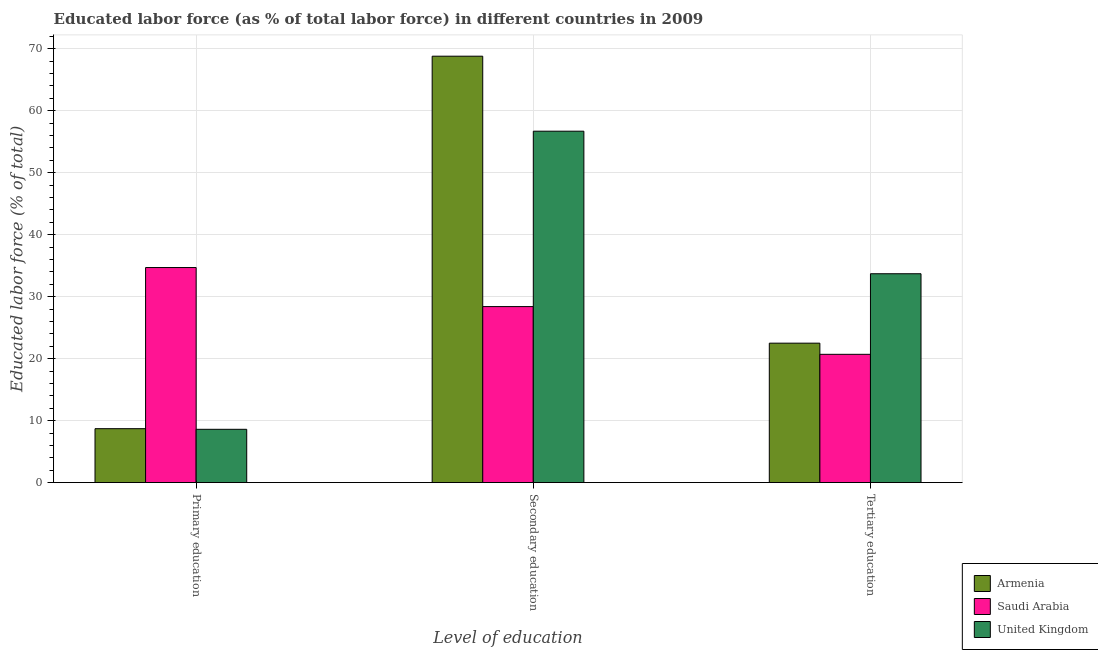Are the number of bars on each tick of the X-axis equal?
Give a very brief answer. Yes. How many bars are there on the 1st tick from the left?
Provide a short and direct response. 3. What is the percentage of labor force who received tertiary education in Saudi Arabia?
Your answer should be compact. 20.7. Across all countries, what is the maximum percentage of labor force who received tertiary education?
Provide a succinct answer. 33.7. Across all countries, what is the minimum percentage of labor force who received primary education?
Your answer should be compact. 8.6. In which country was the percentage of labor force who received primary education maximum?
Provide a succinct answer. Saudi Arabia. In which country was the percentage of labor force who received tertiary education minimum?
Provide a succinct answer. Saudi Arabia. What is the total percentage of labor force who received secondary education in the graph?
Offer a very short reply. 153.9. What is the difference between the percentage of labor force who received tertiary education in United Kingdom and that in Armenia?
Provide a short and direct response. 11.2. What is the difference between the percentage of labor force who received secondary education in United Kingdom and the percentage of labor force who received primary education in Armenia?
Your response must be concise. 48. What is the average percentage of labor force who received primary education per country?
Your response must be concise. 17.33. What is the difference between the percentage of labor force who received tertiary education and percentage of labor force who received primary education in Saudi Arabia?
Ensure brevity in your answer.  -14. What is the ratio of the percentage of labor force who received secondary education in Armenia to that in Saudi Arabia?
Ensure brevity in your answer.  2.42. Is the percentage of labor force who received secondary education in United Kingdom less than that in Armenia?
Give a very brief answer. Yes. Is the difference between the percentage of labor force who received tertiary education in Saudi Arabia and United Kingdom greater than the difference between the percentage of labor force who received secondary education in Saudi Arabia and United Kingdom?
Ensure brevity in your answer.  Yes. What is the difference between the highest and the second highest percentage of labor force who received tertiary education?
Give a very brief answer. 11.2. What is the difference between the highest and the lowest percentage of labor force who received tertiary education?
Offer a very short reply. 13. In how many countries, is the percentage of labor force who received secondary education greater than the average percentage of labor force who received secondary education taken over all countries?
Your answer should be compact. 2. What does the 3rd bar from the right in Tertiary education represents?
Offer a very short reply. Armenia. Is it the case that in every country, the sum of the percentage of labor force who received primary education and percentage of labor force who received secondary education is greater than the percentage of labor force who received tertiary education?
Make the answer very short. Yes. How many countries are there in the graph?
Provide a short and direct response. 3. Where does the legend appear in the graph?
Your answer should be compact. Bottom right. How are the legend labels stacked?
Provide a succinct answer. Vertical. What is the title of the graph?
Provide a short and direct response. Educated labor force (as % of total labor force) in different countries in 2009. Does "Middle East & North Africa (all income levels)" appear as one of the legend labels in the graph?
Your answer should be compact. No. What is the label or title of the X-axis?
Give a very brief answer. Level of education. What is the label or title of the Y-axis?
Your response must be concise. Educated labor force (% of total). What is the Educated labor force (% of total) in Armenia in Primary education?
Offer a very short reply. 8.7. What is the Educated labor force (% of total) in Saudi Arabia in Primary education?
Provide a succinct answer. 34.7. What is the Educated labor force (% of total) in United Kingdom in Primary education?
Offer a terse response. 8.6. What is the Educated labor force (% of total) in Armenia in Secondary education?
Your answer should be compact. 68.8. What is the Educated labor force (% of total) in Saudi Arabia in Secondary education?
Make the answer very short. 28.4. What is the Educated labor force (% of total) in United Kingdom in Secondary education?
Your answer should be compact. 56.7. What is the Educated labor force (% of total) in Saudi Arabia in Tertiary education?
Make the answer very short. 20.7. What is the Educated labor force (% of total) of United Kingdom in Tertiary education?
Offer a terse response. 33.7. Across all Level of education, what is the maximum Educated labor force (% of total) in Armenia?
Ensure brevity in your answer.  68.8. Across all Level of education, what is the maximum Educated labor force (% of total) in Saudi Arabia?
Keep it short and to the point. 34.7. Across all Level of education, what is the maximum Educated labor force (% of total) in United Kingdom?
Provide a succinct answer. 56.7. Across all Level of education, what is the minimum Educated labor force (% of total) of Armenia?
Provide a succinct answer. 8.7. Across all Level of education, what is the minimum Educated labor force (% of total) of Saudi Arabia?
Make the answer very short. 20.7. Across all Level of education, what is the minimum Educated labor force (% of total) of United Kingdom?
Your answer should be very brief. 8.6. What is the total Educated labor force (% of total) in Saudi Arabia in the graph?
Your answer should be very brief. 83.8. What is the total Educated labor force (% of total) in United Kingdom in the graph?
Provide a succinct answer. 99. What is the difference between the Educated labor force (% of total) in Armenia in Primary education and that in Secondary education?
Give a very brief answer. -60.1. What is the difference between the Educated labor force (% of total) of Saudi Arabia in Primary education and that in Secondary education?
Your response must be concise. 6.3. What is the difference between the Educated labor force (% of total) of United Kingdom in Primary education and that in Secondary education?
Offer a very short reply. -48.1. What is the difference between the Educated labor force (% of total) in Saudi Arabia in Primary education and that in Tertiary education?
Provide a succinct answer. 14. What is the difference between the Educated labor force (% of total) in United Kingdom in Primary education and that in Tertiary education?
Provide a succinct answer. -25.1. What is the difference between the Educated labor force (% of total) in Armenia in Secondary education and that in Tertiary education?
Offer a terse response. 46.3. What is the difference between the Educated labor force (% of total) in Saudi Arabia in Secondary education and that in Tertiary education?
Make the answer very short. 7.7. What is the difference between the Educated labor force (% of total) in Armenia in Primary education and the Educated labor force (% of total) in Saudi Arabia in Secondary education?
Provide a succinct answer. -19.7. What is the difference between the Educated labor force (% of total) of Armenia in Primary education and the Educated labor force (% of total) of United Kingdom in Secondary education?
Ensure brevity in your answer.  -48. What is the difference between the Educated labor force (% of total) of Saudi Arabia in Primary education and the Educated labor force (% of total) of United Kingdom in Secondary education?
Offer a terse response. -22. What is the difference between the Educated labor force (% of total) in Armenia in Primary education and the Educated labor force (% of total) in Saudi Arabia in Tertiary education?
Provide a succinct answer. -12. What is the difference between the Educated labor force (% of total) in Armenia in Primary education and the Educated labor force (% of total) in United Kingdom in Tertiary education?
Your answer should be compact. -25. What is the difference between the Educated labor force (% of total) in Saudi Arabia in Primary education and the Educated labor force (% of total) in United Kingdom in Tertiary education?
Offer a very short reply. 1. What is the difference between the Educated labor force (% of total) in Armenia in Secondary education and the Educated labor force (% of total) in Saudi Arabia in Tertiary education?
Provide a short and direct response. 48.1. What is the difference between the Educated labor force (% of total) in Armenia in Secondary education and the Educated labor force (% of total) in United Kingdom in Tertiary education?
Your response must be concise. 35.1. What is the difference between the Educated labor force (% of total) in Saudi Arabia in Secondary education and the Educated labor force (% of total) in United Kingdom in Tertiary education?
Provide a succinct answer. -5.3. What is the average Educated labor force (% of total) of Armenia per Level of education?
Provide a short and direct response. 33.33. What is the average Educated labor force (% of total) of Saudi Arabia per Level of education?
Your answer should be compact. 27.93. What is the difference between the Educated labor force (% of total) in Armenia and Educated labor force (% of total) in Saudi Arabia in Primary education?
Ensure brevity in your answer.  -26. What is the difference between the Educated labor force (% of total) of Armenia and Educated labor force (% of total) of United Kingdom in Primary education?
Your response must be concise. 0.1. What is the difference between the Educated labor force (% of total) of Saudi Arabia and Educated labor force (% of total) of United Kingdom in Primary education?
Your response must be concise. 26.1. What is the difference between the Educated labor force (% of total) of Armenia and Educated labor force (% of total) of Saudi Arabia in Secondary education?
Your answer should be compact. 40.4. What is the difference between the Educated labor force (% of total) of Saudi Arabia and Educated labor force (% of total) of United Kingdom in Secondary education?
Your answer should be compact. -28.3. What is the difference between the Educated labor force (% of total) of Armenia and Educated labor force (% of total) of Saudi Arabia in Tertiary education?
Keep it short and to the point. 1.8. What is the difference between the Educated labor force (% of total) in Saudi Arabia and Educated labor force (% of total) in United Kingdom in Tertiary education?
Offer a terse response. -13. What is the ratio of the Educated labor force (% of total) in Armenia in Primary education to that in Secondary education?
Offer a very short reply. 0.13. What is the ratio of the Educated labor force (% of total) in Saudi Arabia in Primary education to that in Secondary education?
Your answer should be very brief. 1.22. What is the ratio of the Educated labor force (% of total) in United Kingdom in Primary education to that in Secondary education?
Offer a very short reply. 0.15. What is the ratio of the Educated labor force (% of total) of Armenia in Primary education to that in Tertiary education?
Offer a very short reply. 0.39. What is the ratio of the Educated labor force (% of total) of Saudi Arabia in Primary education to that in Tertiary education?
Your answer should be very brief. 1.68. What is the ratio of the Educated labor force (% of total) in United Kingdom in Primary education to that in Tertiary education?
Your answer should be compact. 0.26. What is the ratio of the Educated labor force (% of total) of Armenia in Secondary education to that in Tertiary education?
Your response must be concise. 3.06. What is the ratio of the Educated labor force (% of total) in Saudi Arabia in Secondary education to that in Tertiary education?
Your answer should be very brief. 1.37. What is the ratio of the Educated labor force (% of total) in United Kingdom in Secondary education to that in Tertiary education?
Your answer should be very brief. 1.68. What is the difference between the highest and the second highest Educated labor force (% of total) in Armenia?
Give a very brief answer. 46.3. What is the difference between the highest and the lowest Educated labor force (% of total) in Armenia?
Give a very brief answer. 60.1. What is the difference between the highest and the lowest Educated labor force (% of total) in United Kingdom?
Your answer should be very brief. 48.1. 